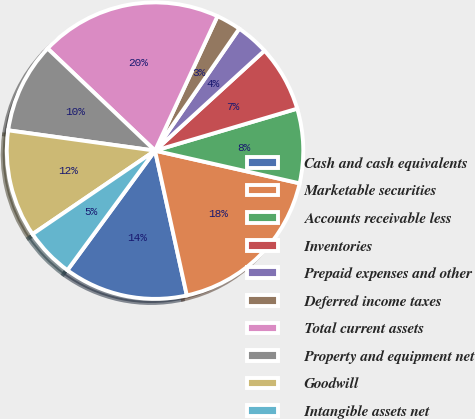Convert chart. <chart><loc_0><loc_0><loc_500><loc_500><pie_chart><fcel>Cash and cash equivalents<fcel>Marketable securities<fcel>Accounts receivable less<fcel>Inventories<fcel>Prepaid expenses and other<fcel>Deferred income taxes<fcel>Total current assets<fcel>Property and equipment net<fcel>Goodwill<fcel>Intangible assets net<nl><fcel>13.51%<fcel>18.02%<fcel>8.11%<fcel>7.21%<fcel>3.6%<fcel>2.7%<fcel>19.82%<fcel>9.91%<fcel>11.71%<fcel>5.41%<nl></chart> 